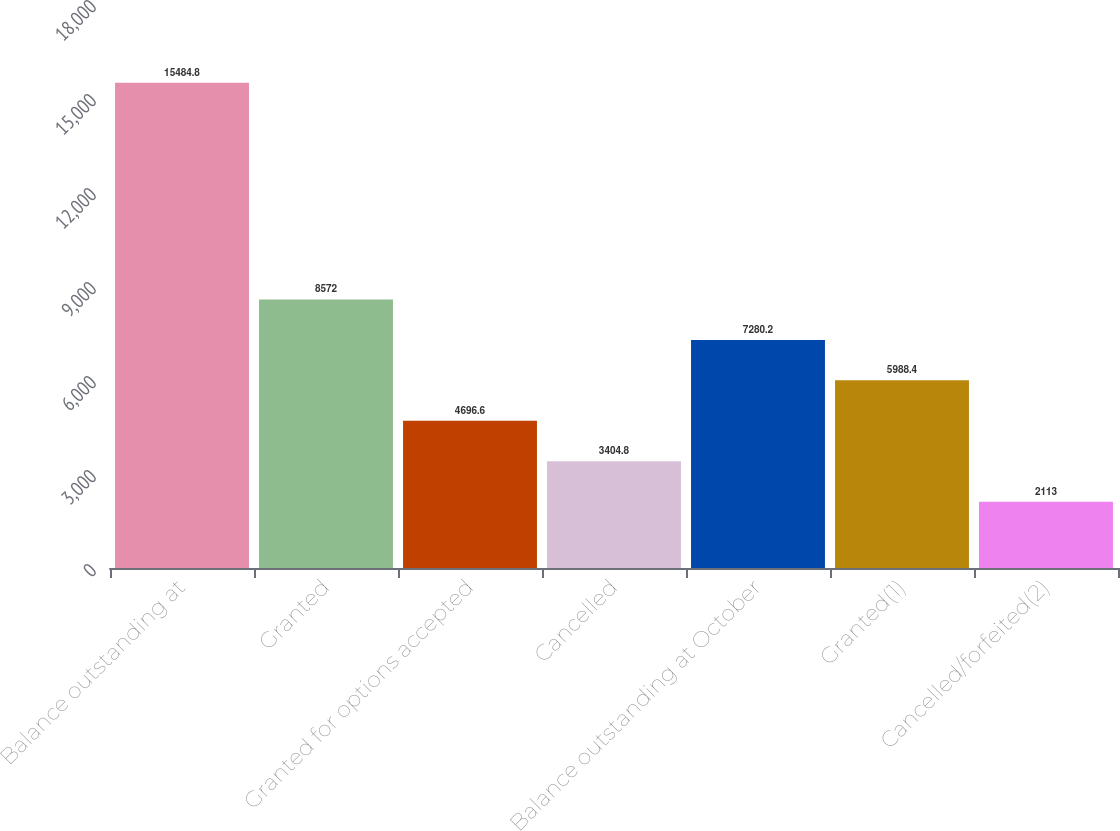<chart> <loc_0><loc_0><loc_500><loc_500><bar_chart><fcel>Balance outstanding at<fcel>Granted<fcel>Granted for options accepted<fcel>Cancelled<fcel>Balance outstanding at October<fcel>Granted(1)<fcel>Cancelled/forfeited(2)<nl><fcel>15484.8<fcel>8572<fcel>4696.6<fcel>3404.8<fcel>7280.2<fcel>5988.4<fcel>2113<nl></chart> 